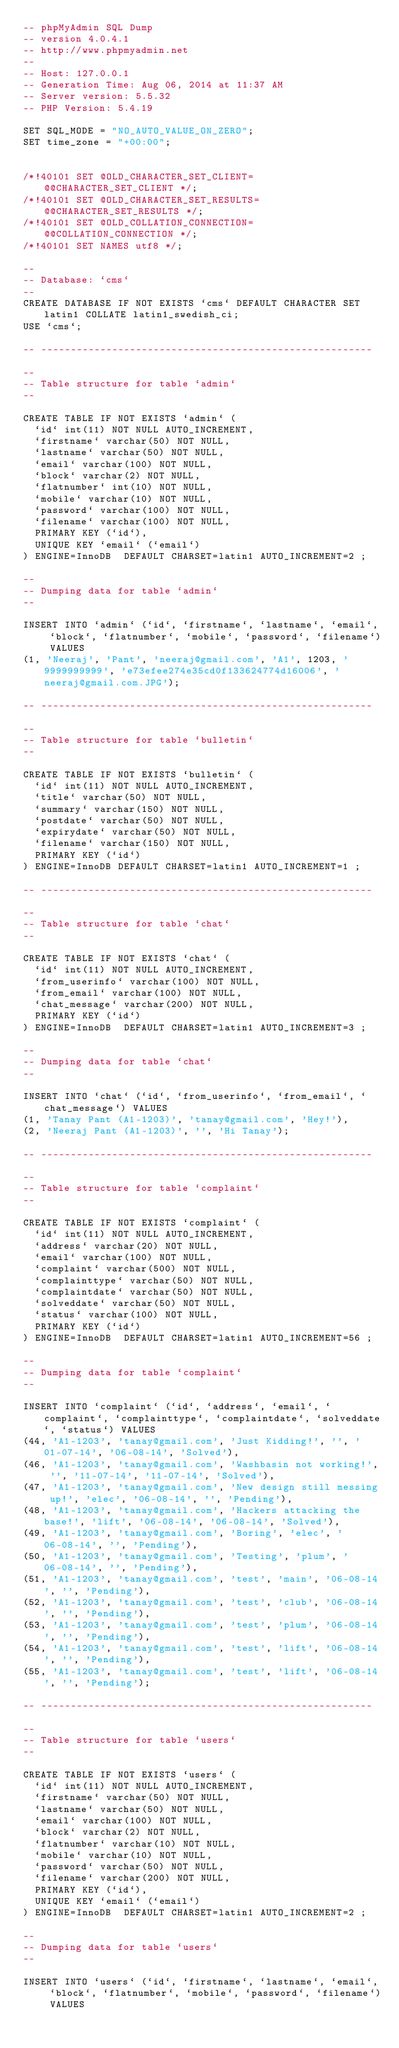<code> <loc_0><loc_0><loc_500><loc_500><_SQL_>-- phpMyAdmin SQL Dump
-- version 4.0.4.1
-- http://www.phpmyadmin.net
--
-- Host: 127.0.0.1
-- Generation Time: Aug 06, 2014 at 11:37 AM
-- Server version: 5.5.32
-- PHP Version: 5.4.19

SET SQL_MODE = "NO_AUTO_VALUE_ON_ZERO";
SET time_zone = "+00:00";


/*!40101 SET @OLD_CHARACTER_SET_CLIENT=@@CHARACTER_SET_CLIENT */;
/*!40101 SET @OLD_CHARACTER_SET_RESULTS=@@CHARACTER_SET_RESULTS */;
/*!40101 SET @OLD_COLLATION_CONNECTION=@@COLLATION_CONNECTION */;
/*!40101 SET NAMES utf8 */;

--
-- Database: `cms`
--
CREATE DATABASE IF NOT EXISTS `cms` DEFAULT CHARACTER SET latin1 COLLATE latin1_swedish_ci;
USE `cms`;

-- --------------------------------------------------------

--
-- Table structure for table `admin`
--

CREATE TABLE IF NOT EXISTS `admin` (
  `id` int(11) NOT NULL AUTO_INCREMENT,
  `firstname` varchar(50) NOT NULL,
  `lastname` varchar(50) NOT NULL,
  `email` varchar(100) NOT NULL,
  `block` varchar(2) NOT NULL,
  `flatnumber` int(10) NOT NULL,
  `mobile` varchar(10) NOT NULL,
  `password` varchar(100) NOT NULL,
  `filename` varchar(100) NOT NULL,
  PRIMARY KEY (`id`),
  UNIQUE KEY `email` (`email`)
) ENGINE=InnoDB  DEFAULT CHARSET=latin1 AUTO_INCREMENT=2 ;

--
-- Dumping data for table `admin`
--

INSERT INTO `admin` (`id`, `firstname`, `lastname`, `email`, `block`, `flatnumber`, `mobile`, `password`, `filename`) VALUES
(1, 'Neeraj', 'Pant', 'neeraj@gmail.com', 'A1', 1203, '9999999999', 'e73efee274e35cd0f133624774d16006', 'neeraj@gmail.com.JPG');

-- --------------------------------------------------------

--
-- Table structure for table `bulletin`
--

CREATE TABLE IF NOT EXISTS `bulletin` (
  `id` int(11) NOT NULL AUTO_INCREMENT,
  `title` varchar(50) NOT NULL,
  `summary` varchar(150) NOT NULL,
  `postdate` varchar(50) NOT NULL,
  `expirydate` varchar(50) NOT NULL,
  `filename` varchar(150) NOT NULL,
  PRIMARY KEY (`id`)
) ENGINE=InnoDB DEFAULT CHARSET=latin1 AUTO_INCREMENT=1 ;

-- --------------------------------------------------------

--
-- Table structure for table `chat`
--

CREATE TABLE IF NOT EXISTS `chat` (
  `id` int(11) NOT NULL AUTO_INCREMENT,
  `from_userinfo` varchar(100) NOT NULL,
  `from_email` varchar(100) NOT NULL,
  `chat_message` varchar(200) NOT NULL,
  PRIMARY KEY (`id`)
) ENGINE=InnoDB  DEFAULT CHARSET=latin1 AUTO_INCREMENT=3 ;

--
-- Dumping data for table `chat`
--

INSERT INTO `chat` (`id`, `from_userinfo`, `from_email`, `chat_message`) VALUES
(1, 'Tanay Pant (A1-1203)', 'tanay@gmail.com', 'Hey!'),
(2, 'Neeraj Pant (A1-1203)', '', 'Hi Tanay');

-- --------------------------------------------------------

--
-- Table structure for table `complaint`
--

CREATE TABLE IF NOT EXISTS `complaint` (
  `id` int(11) NOT NULL AUTO_INCREMENT,
  `address` varchar(20) NOT NULL,
  `email` varchar(100) NOT NULL,
  `complaint` varchar(500) NOT NULL,
  `complainttype` varchar(50) NOT NULL,
  `complaintdate` varchar(50) NOT NULL,
  `solveddate` varchar(50) NOT NULL,
  `status` varchar(100) NOT NULL,
  PRIMARY KEY (`id`)
) ENGINE=InnoDB  DEFAULT CHARSET=latin1 AUTO_INCREMENT=56 ;

--
-- Dumping data for table `complaint`
--

INSERT INTO `complaint` (`id`, `address`, `email`, `complaint`, `complainttype`, `complaintdate`, `solveddate`, `status`) VALUES
(44, 'A1-1203', 'tanay@gmail.com', 'Just Kidding!', '', '01-07-14', '06-08-14', 'Solved'),
(46, 'A1-1203', 'tanay@gmail.com', 'Washbasin not working!', '', '11-07-14', '11-07-14', 'Solved'),
(47, 'A1-1203', 'tanay@gmail.com', 'New design still messing up!', 'elec', '06-08-14', '', 'Pending'),
(48, 'A1-1203', 'tanay@gmail.com', 'Hackers attacking the base!', 'lift', '06-08-14', '06-08-14', 'Solved'),
(49, 'A1-1203', 'tanay@gmail.com', 'Boring', 'elec', '06-08-14', '', 'Pending'),
(50, 'A1-1203', 'tanay@gmail.com', 'Testing', 'plum', '06-08-14', '', 'Pending'),
(51, 'A1-1203', 'tanay@gmail.com', 'test', 'main', '06-08-14', '', 'Pending'),
(52, 'A1-1203', 'tanay@gmail.com', 'test', 'club', '06-08-14', '', 'Pending'),
(53, 'A1-1203', 'tanay@gmail.com', 'test', 'plum', '06-08-14', '', 'Pending'),
(54, 'A1-1203', 'tanay@gmail.com', 'test', 'lift', '06-08-14', '', 'Pending'),
(55, 'A1-1203', 'tanay@gmail.com', 'test', 'lift', '06-08-14', '', 'Pending');

-- --------------------------------------------------------

--
-- Table structure for table `users`
--

CREATE TABLE IF NOT EXISTS `users` (
  `id` int(11) NOT NULL AUTO_INCREMENT,
  `firstname` varchar(50) NOT NULL,
  `lastname` varchar(50) NOT NULL,
  `email` varchar(100) NOT NULL,
  `block` varchar(2) NOT NULL,
  `flatnumber` varchar(10) NOT NULL,
  `mobile` varchar(10) NOT NULL,
  `password` varchar(50) NOT NULL,
  `filename` varchar(200) NOT NULL,
  PRIMARY KEY (`id`),
  UNIQUE KEY `email` (`email`)
) ENGINE=InnoDB  DEFAULT CHARSET=latin1 AUTO_INCREMENT=2 ;

--
-- Dumping data for table `users`
--

INSERT INTO `users` (`id`, `firstname`, `lastname`, `email`, `block`, `flatnumber`, `mobile`, `password`, `filename`) VALUES</code> 